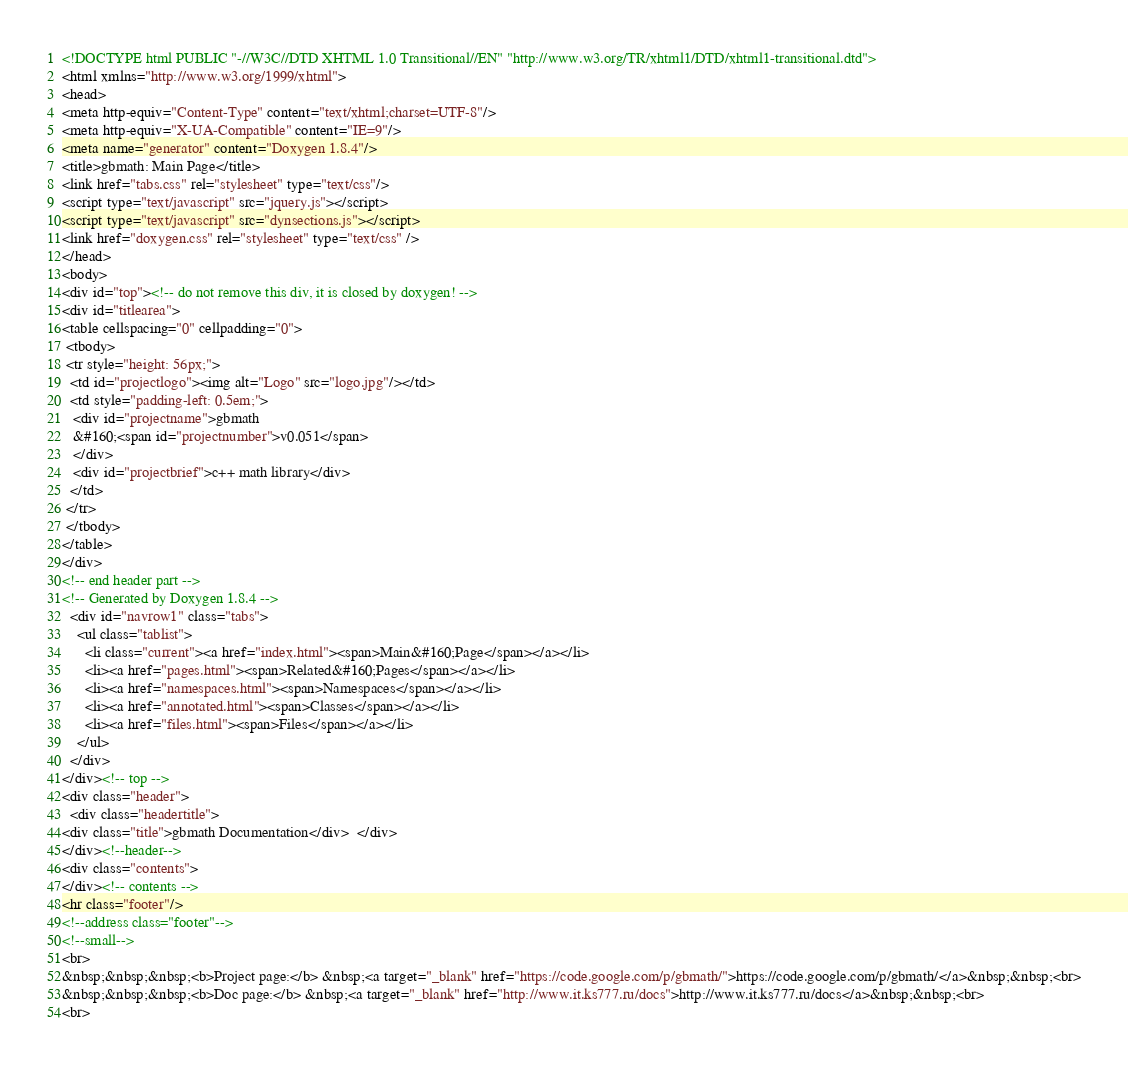Convert code to text. <code><loc_0><loc_0><loc_500><loc_500><_HTML_><!DOCTYPE html PUBLIC "-//W3C//DTD XHTML 1.0 Transitional//EN" "http://www.w3.org/TR/xhtml1/DTD/xhtml1-transitional.dtd">
<html xmlns="http://www.w3.org/1999/xhtml">
<head>
<meta http-equiv="Content-Type" content="text/xhtml;charset=UTF-8"/>
<meta http-equiv="X-UA-Compatible" content="IE=9"/>
<meta name="generator" content="Doxygen 1.8.4"/>
<title>gbmath: Main Page</title>
<link href="tabs.css" rel="stylesheet" type="text/css"/>
<script type="text/javascript" src="jquery.js"></script>
<script type="text/javascript" src="dynsections.js"></script>
<link href="doxygen.css" rel="stylesheet" type="text/css" />
</head>
<body>
<div id="top"><!-- do not remove this div, it is closed by doxygen! -->
<div id="titlearea">
<table cellspacing="0" cellpadding="0">
 <tbody>
 <tr style="height: 56px;">
  <td id="projectlogo"><img alt="Logo" src="logo.jpg"/></td>
  <td style="padding-left: 0.5em;">
   <div id="projectname">gbmath
   &#160;<span id="projectnumber">v0.051</span>
   </div>
   <div id="projectbrief">c++ math library</div>
  </td>
 </tr>
 </tbody>
</table>
</div>
<!-- end header part -->
<!-- Generated by Doxygen 1.8.4 -->
  <div id="navrow1" class="tabs">
    <ul class="tablist">
      <li class="current"><a href="index.html"><span>Main&#160;Page</span></a></li>
      <li><a href="pages.html"><span>Related&#160;Pages</span></a></li>
      <li><a href="namespaces.html"><span>Namespaces</span></a></li>
      <li><a href="annotated.html"><span>Classes</span></a></li>
      <li><a href="files.html"><span>Files</span></a></li>
    </ul>
  </div>
</div><!-- top -->
<div class="header">
  <div class="headertitle">
<div class="title">gbmath Documentation</div>  </div>
</div><!--header-->
<div class="contents">
</div><!-- contents -->
<hr class="footer"/>
<!--address class="footer"-->
<!--small-->
<br>
&nbsp;&nbsp;&nbsp;<b>Project page:</b> &nbsp;<a target="_blank" href="https://code.google.com/p/gbmath/">https://code.google.com/p/gbmath/</a>&nbsp;&nbsp;<br>
&nbsp;&nbsp;&nbsp;<b>Doc page:</b> &nbsp;<a target="_blank" href="http://www.it.ks777.ru/docs">http://www.it.ks777.ru/docs</a>&nbsp;&nbsp;<br>
<br></code> 